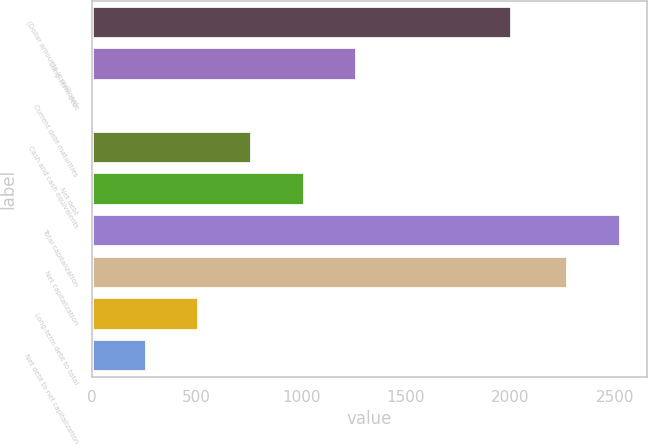Convert chart. <chart><loc_0><loc_0><loc_500><loc_500><bar_chart><fcel>(Dollar amounts in millions)<fcel>Long-term debt<fcel>Current debt maturities<fcel>Cash and cash equivalents<fcel>Net debt<fcel>Total capitalization<fcel>Net capitalization<fcel>Long-term debt to total<fcel>Net debt to net capitalization<nl><fcel>2009<fcel>1268<fcel>10<fcel>764.8<fcel>1016.4<fcel>2527.6<fcel>2276<fcel>513.2<fcel>261.6<nl></chart> 